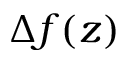<formula> <loc_0><loc_0><loc_500><loc_500>\Delta f ( z )</formula> 